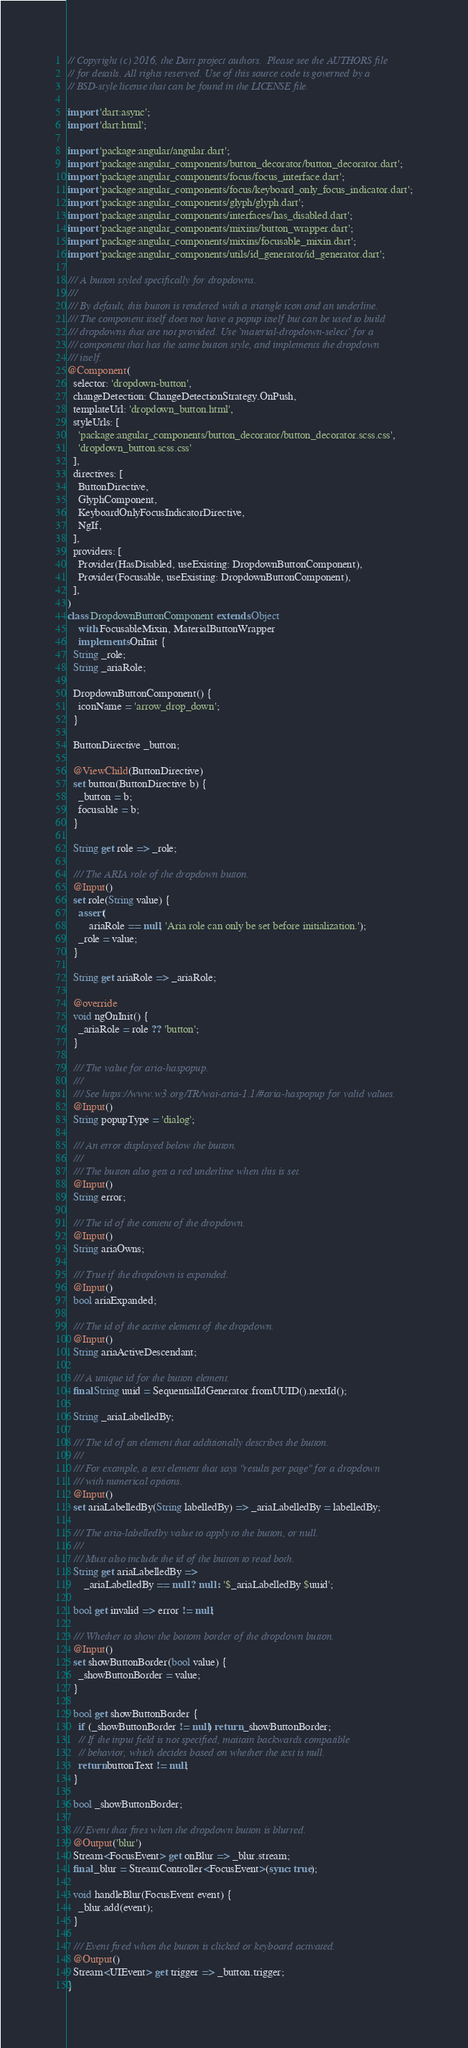Convert code to text. <code><loc_0><loc_0><loc_500><loc_500><_Dart_>// Copyright (c) 2016, the Dart project authors.  Please see the AUTHORS file
// for details. All rights reserved. Use of this source code is governed by a
// BSD-style license that can be found in the LICENSE file.

import 'dart:async';
import 'dart:html';

import 'package:angular/angular.dart';
import 'package:angular_components/button_decorator/button_decorator.dart';
import 'package:angular_components/focus/focus_interface.dart';
import 'package:angular_components/focus/keyboard_only_focus_indicator.dart';
import 'package:angular_components/glyph/glyph.dart';
import 'package:angular_components/interfaces/has_disabled.dart';
import 'package:angular_components/mixins/button_wrapper.dart';
import 'package:angular_components/mixins/focusable_mixin.dart';
import 'package:angular_components/utils/id_generator/id_generator.dart';

/// A button styled specifically for dropdowns.
///
/// By default, this button is rendered with a triangle icon and an underline.
/// The component itself does not have a popup itself but can be used to build
/// dropdowns that are not provided. Use `material-dropdown-select` for a
/// component that has the same button style, and implements the dropdown
/// itself.
@Component(
  selector: 'dropdown-button',
  changeDetection: ChangeDetectionStrategy.OnPush,
  templateUrl: 'dropdown_button.html',
  styleUrls: [
    'package:angular_components/button_decorator/button_decorator.scss.css',
    'dropdown_button.scss.css'
  ],
  directives: [
    ButtonDirective,
    GlyphComponent,
    KeyboardOnlyFocusIndicatorDirective,
    NgIf,
  ],
  providers: [
    Provider(HasDisabled, useExisting: DropdownButtonComponent),
    Provider(Focusable, useExisting: DropdownButtonComponent),
  ],
)
class DropdownButtonComponent extends Object
    with FocusableMixin, MaterialButtonWrapper
    implements OnInit {
  String _role;
  String _ariaRole;

  DropdownButtonComponent() {
    iconName = 'arrow_drop_down';
  }

  ButtonDirective _button;

  @ViewChild(ButtonDirective)
  set button(ButtonDirective b) {
    _button = b;
    focusable = b;
  }

  String get role => _role;

  /// The ARIA role of the dropdown button.
  @Input()
  set role(String value) {
    assert(
        ariaRole == null, 'Aria role can only be set before initialization.');
    _role = value;
  }

  String get ariaRole => _ariaRole;

  @override
  void ngOnInit() {
    _ariaRole = role ?? 'button';
  }

  /// The value for aria-haspopup.
  ///
  /// See https://www.w3.org/TR/wai-aria-1.1/#aria-haspopup for valid values.
  @Input()
  String popupType = 'dialog';

  /// An error displayed below the button.
  ///
  /// The button also gets a red underline when this is set.
  @Input()
  String error;

  /// The id of the content of the dropdown.
  @Input()
  String ariaOwns;

  /// True if the dropdown is expanded.
  @Input()
  bool ariaExpanded;

  /// The id of the active element of the dropdown.
  @Input()
  String ariaActiveDescendant;

  /// A unique id for the button element.
  final String uuid = SequentialIdGenerator.fromUUID().nextId();

  String _ariaLabelledBy;

  /// The id of an element that additionally describes the button.
  ///
  /// For example, a text element that says "results per page" for a dropdown
  /// with numerical options.
  @Input()
  set ariaLabelledBy(String labelledBy) => _ariaLabelledBy = labelledBy;

  /// The aria-labelledby value to apply to the button, or null.
  ///
  /// Must also include the id of the button to read both.
  String get ariaLabelledBy =>
      _ariaLabelledBy == null ? null : '$_ariaLabelledBy $uuid';

  bool get invalid => error != null;

  /// Whether to show the bottom border of the dropdown button.
  @Input()
  set showButtonBorder(bool value) {
    _showButtonBorder = value;
  }

  bool get showButtonBorder {
    if (_showButtonBorder != null) return _showButtonBorder;
    // If the input field is not specified, maitain backwards compatible
    // behavior, which decides based on whether the text is null.
    return buttonText != null;
  }

  bool _showButtonBorder;

  /// Event that fires when the dropdown button is blurred.
  @Output('blur')
  Stream<FocusEvent> get onBlur => _blur.stream;
  final _blur = StreamController<FocusEvent>(sync: true);

  void handleBlur(FocusEvent event) {
    _blur.add(event);
  }

  /// Event fired when the button is clicked or keyboard activated.
  @Output()
  Stream<UIEvent> get trigger => _button.trigger;
}
</code> 